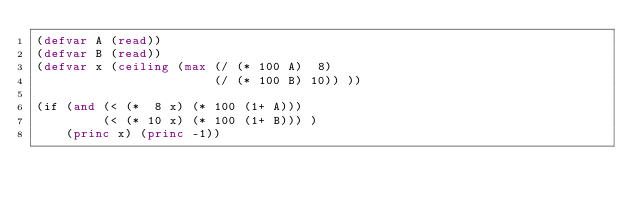<code> <loc_0><loc_0><loc_500><loc_500><_Lisp_>(defvar A (read))
(defvar B (read))
(defvar x (ceiling (max (/ (* 100 A)  8)
                        (/ (* 100 B) 10)) ))

(if (and (< (*  8 x) (* 100 (1+ A)))
         (< (* 10 x) (* 100 (1+ B))) )
    (princ x) (princ -1))</code> 